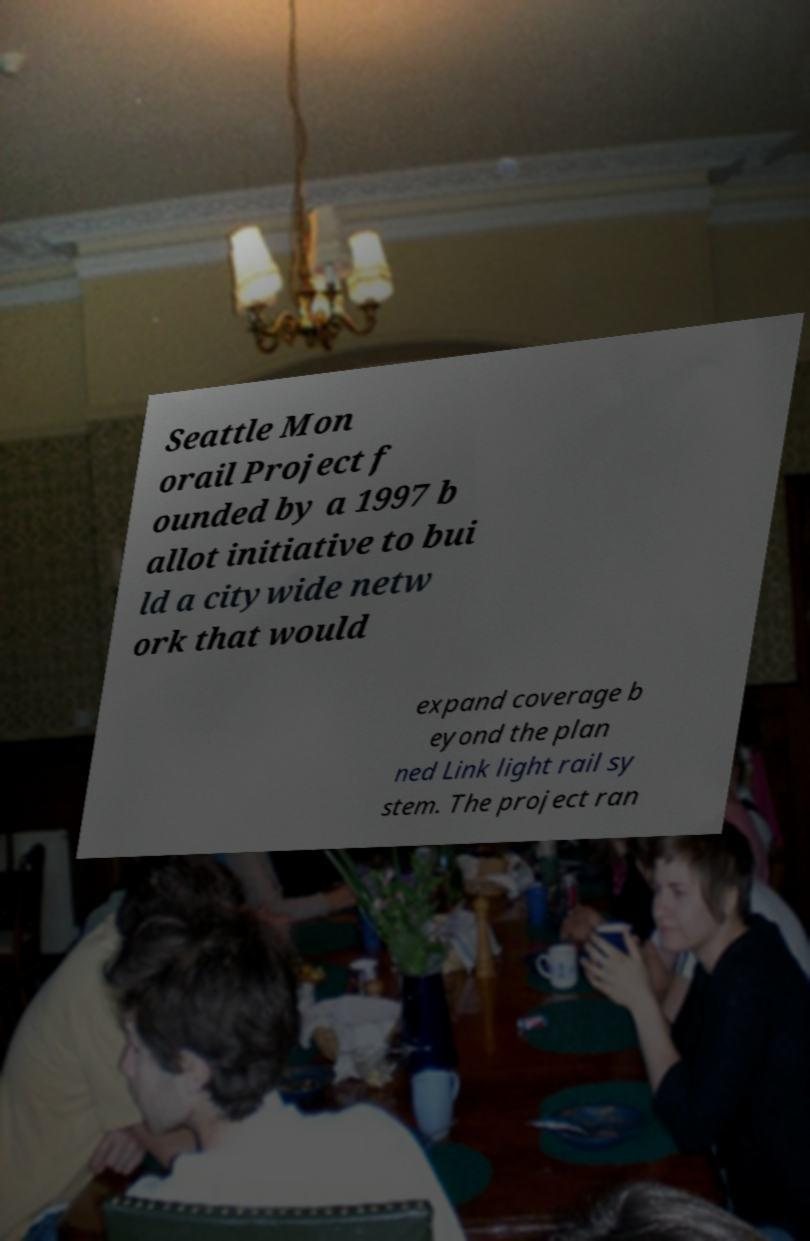Can you read and provide the text displayed in the image?This photo seems to have some interesting text. Can you extract and type it out for me? Seattle Mon orail Project f ounded by a 1997 b allot initiative to bui ld a citywide netw ork that would expand coverage b eyond the plan ned Link light rail sy stem. The project ran 